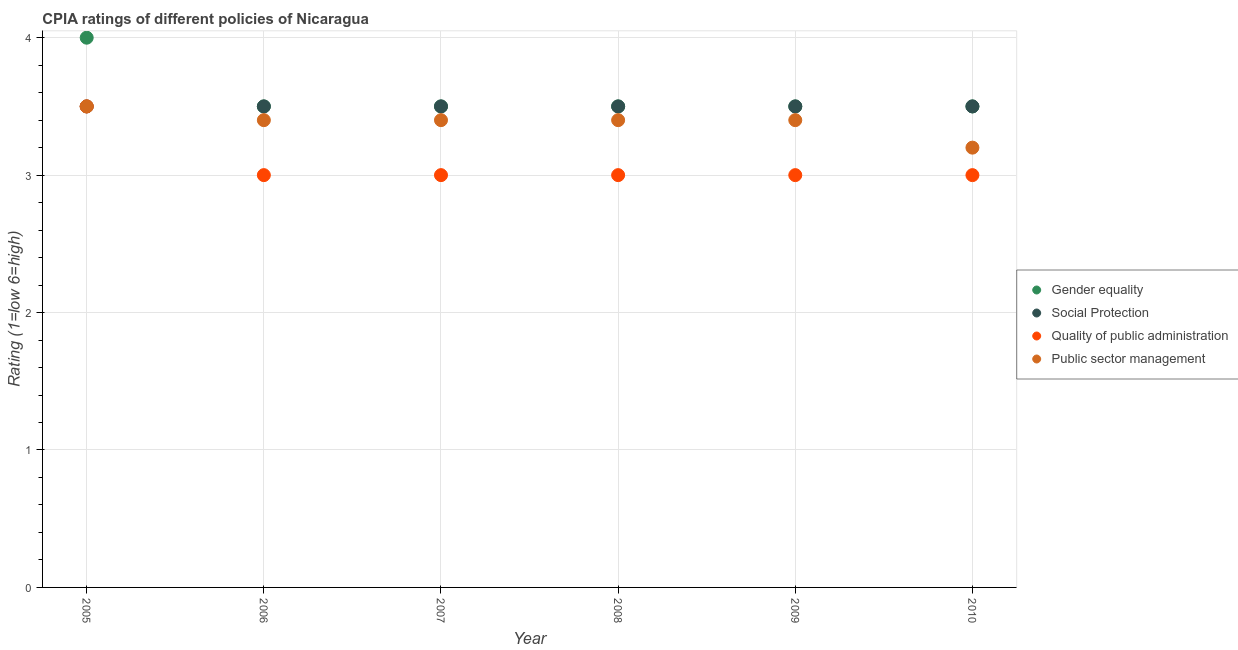How many different coloured dotlines are there?
Make the answer very short. 4. Is the number of dotlines equal to the number of legend labels?
Your answer should be very brief. Yes. Across all years, what is the minimum cpia rating of public sector management?
Provide a succinct answer. 3.2. In which year was the cpia rating of social protection maximum?
Your answer should be very brief. 2005. In which year was the cpia rating of social protection minimum?
Offer a terse response. 2005. What is the total cpia rating of gender equality in the graph?
Offer a terse response. 21.5. What is the difference between the cpia rating of public sector management in 2008 and the cpia rating of gender equality in 2005?
Ensure brevity in your answer.  -0.6. What is the average cpia rating of public sector management per year?
Make the answer very short. 3.38. In how many years, is the cpia rating of public sector management greater than 1.4?
Provide a short and direct response. 6. What is the ratio of the cpia rating of social protection in 2008 to that in 2009?
Ensure brevity in your answer.  1. Is the cpia rating of quality of public administration in 2005 less than that in 2008?
Ensure brevity in your answer.  No. Is the difference between the cpia rating of public sector management in 2006 and 2007 greater than the difference between the cpia rating of quality of public administration in 2006 and 2007?
Keep it short and to the point. No. What is the difference between the highest and the second highest cpia rating of public sector management?
Your response must be concise. 0.1. In how many years, is the cpia rating of social protection greater than the average cpia rating of social protection taken over all years?
Offer a terse response. 0. Is the sum of the cpia rating of quality of public administration in 2006 and 2010 greater than the maximum cpia rating of gender equality across all years?
Offer a terse response. Yes. Is it the case that in every year, the sum of the cpia rating of gender equality and cpia rating of social protection is greater than the cpia rating of quality of public administration?
Offer a terse response. Yes. Does the cpia rating of social protection monotonically increase over the years?
Make the answer very short. No. Is the cpia rating of quality of public administration strictly greater than the cpia rating of public sector management over the years?
Offer a very short reply. No. How many dotlines are there?
Keep it short and to the point. 4. How many years are there in the graph?
Provide a succinct answer. 6. What is the difference between two consecutive major ticks on the Y-axis?
Provide a succinct answer. 1. Are the values on the major ticks of Y-axis written in scientific E-notation?
Offer a very short reply. No. Does the graph contain any zero values?
Give a very brief answer. No. Where does the legend appear in the graph?
Offer a terse response. Center right. How are the legend labels stacked?
Offer a very short reply. Vertical. What is the title of the graph?
Keep it short and to the point. CPIA ratings of different policies of Nicaragua. What is the Rating (1=low 6=high) of Social Protection in 2005?
Offer a very short reply. 3.5. What is the Rating (1=low 6=high) in Public sector management in 2005?
Give a very brief answer. 3.5. What is the Rating (1=low 6=high) of Social Protection in 2006?
Offer a terse response. 3.5. What is the Rating (1=low 6=high) in Quality of public administration in 2006?
Offer a terse response. 3. What is the Rating (1=low 6=high) in Public sector management in 2006?
Keep it short and to the point. 3.4. What is the Rating (1=low 6=high) in Social Protection in 2007?
Your response must be concise. 3.5. What is the Rating (1=low 6=high) in Quality of public administration in 2007?
Give a very brief answer. 3. What is the Rating (1=low 6=high) in Public sector management in 2007?
Offer a terse response. 3.4. What is the Rating (1=low 6=high) in Gender equality in 2008?
Keep it short and to the point. 3.5. What is the Rating (1=low 6=high) of Social Protection in 2008?
Make the answer very short. 3.5. What is the Rating (1=low 6=high) in Public sector management in 2008?
Offer a very short reply. 3.4. What is the Rating (1=low 6=high) of Social Protection in 2009?
Keep it short and to the point. 3.5. What is the Rating (1=low 6=high) in Quality of public administration in 2009?
Ensure brevity in your answer.  3. What is the Rating (1=low 6=high) of Social Protection in 2010?
Make the answer very short. 3.5. Across all years, what is the maximum Rating (1=low 6=high) of Gender equality?
Your answer should be very brief. 4. Across all years, what is the maximum Rating (1=low 6=high) of Quality of public administration?
Provide a short and direct response. 3.5. Across all years, what is the minimum Rating (1=low 6=high) in Gender equality?
Provide a short and direct response. 3.5. Across all years, what is the minimum Rating (1=low 6=high) in Social Protection?
Your response must be concise. 3.5. What is the total Rating (1=low 6=high) in Gender equality in the graph?
Your answer should be very brief. 21.5. What is the total Rating (1=low 6=high) in Public sector management in the graph?
Keep it short and to the point. 20.3. What is the difference between the Rating (1=low 6=high) in Quality of public administration in 2005 and that in 2006?
Provide a short and direct response. 0.5. What is the difference between the Rating (1=low 6=high) of Gender equality in 2005 and that in 2007?
Provide a succinct answer. 0.5. What is the difference between the Rating (1=low 6=high) of Social Protection in 2005 and that in 2007?
Provide a short and direct response. 0. What is the difference between the Rating (1=low 6=high) of Public sector management in 2005 and that in 2007?
Offer a terse response. 0.1. What is the difference between the Rating (1=low 6=high) of Gender equality in 2005 and that in 2008?
Offer a terse response. 0.5. What is the difference between the Rating (1=low 6=high) of Social Protection in 2005 and that in 2008?
Provide a short and direct response. 0. What is the difference between the Rating (1=low 6=high) of Public sector management in 2005 and that in 2008?
Offer a terse response. 0.1. What is the difference between the Rating (1=low 6=high) of Gender equality in 2005 and that in 2009?
Make the answer very short. 0.5. What is the difference between the Rating (1=low 6=high) of Social Protection in 2005 and that in 2009?
Give a very brief answer. 0. What is the difference between the Rating (1=low 6=high) of Public sector management in 2005 and that in 2009?
Offer a very short reply. 0.1. What is the difference between the Rating (1=low 6=high) in Social Protection in 2005 and that in 2010?
Offer a terse response. 0. What is the difference between the Rating (1=low 6=high) of Quality of public administration in 2005 and that in 2010?
Offer a very short reply. 0.5. What is the difference between the Rating (1=low 6=high) of Public sector management in 2005 and that in 2010?
Provide a succinct answer. 0.3. What is the difference between the Rating (1=low 6=high) in Gender equality in 2006 and that in 2007?
Your answer should be compact. 0. What is the difference between the Rating (1=low 6=high) in Social Protection in 2006 and that in 2007?
Offer a very short reply. 0. What is the difference between the Rating (1=low 6=high) in Quality of public administration in 2006 and that in 2007?
Your answer should be compact. 0. What is the difference between the Rating (1=low 6=high) of Gender equality in 2006 and that in 2008?
Make the answer very short. 0. What is the difference between the Rating (1=low 6=high) in Quality of public administration in 2006 and that in 2008?
Give a very brief answer. 0. What is the difference between the Rating (1=low 6=high) of Public sector management in 2006 and that in 2008?
Give a very brief answer. 0. What is the difference between the Rating (1=low 6=high) of Quality of public administration in 2006 and that in 2010?
Give a very brief answer. 0. What is the difference between the Rating (1=low 6=high) in Public sector management in 2006 and that in 2010?
Your answer should be very brief. 0.2. What is the difference between the Rating (1=low 6=high) of Quality of public administration in 2007 and that in 2008?
Make the answer very short. 0. What is the difference between the Rating (1=low 6=high) in Public sector management in 2007 and that in 2008?
Give a very brief answer. 0. What is the difference between the Rating (1=low 6=high) of Gender equality in 2007 and that in 2009?
Ensure brevity in your answer.  0. What is the difference between the Rating (1=low 6=high) in Social Protection in 2007 and that in 2009?
Provide a succinct answer. 0. What is the difference between the Rating (1=low 6=high) of Public sector management in 2007 and that in 2009?
Ensure brevity in your answer.  0. What is the difference between the Rating (1=low 6=high) of Quality of public administration in 2007 and that in 2010?
Your answer should be very brief. 0. What is the difference between the Rating (1=low 6=high) of Public sector management in 2007 and that in 2010?
Provide a short and direct response. 0.2. What is the difference between the Rating (1=low 6=high) of Social Protection in 2008 and that in 2009?
Make the answer very short. 0. What is the difference between the Rating (1=low 6=high) in Quality of public administration in 2008 and that in 2009?
Your answer should be very brief. 0. What is the difference between the Rating (1=low 6=high) of Public sector management in 2008 and that in 2009?
Offer a terse response. 0. What is the difference between the Rating (1=low 6=high) in Social Protection in 2008 and that in 2010?
Keep it short and to the point. 0. What is the difference between the Rating (1=low 6=high) in Quality of public administration in 2008 and that in 2010?
Your answer should be compact. 0. What is the difference between the Rating (1=low 6=high) in Public sector management in 2008 and that in 2010?
Provide a succinct answer. 0.2. What is the difference between the Rating (1=low 6=high) of Gender equality in 2009 and that in 2010?
Offer a terse response. 0. What is the difference between the Rating (1=low 6=high) of Public sector management in 2009 and that in 2010?
Provide a succinct answer. 0.2. What is the difference between the Rating (1=low 6=high) of Gender equality in 2005 and the Rating (1=low 6=high) of Social Protection in 2006?
Provide a succinct answer. 0.5. What is the difference between the Rating (1=low 6=high) of Gender equality in 2005 and the Rating (1=low 6=high) of Quality of public administration in 2006?
Your response must be concise. 1. What is the difference between the Rating (1=low 6=high) of Gender equality in 2005 and the Rating (1=low 6=high) of Public sector management in 2006?
Your response must be concise. 0.6. What is the difference between the Rating (1=low 6=high) of Social Protection in 2005 and the Rating (1=low 6=high) of Public sector management in 2006?
Ensure brevity in your answer.  0.1. What is the difference between the Rating (1=low 6=high) of Gender equality in 2005 and the Rating (1=low 6=high) of Social Protection in 2007?
Provide a short and direct response. 0.5. What is the difference between the Rating (1=low 6=high) in Social Protection in 2005 and the Rating (1=low 6=high) in Quality of public administration in 2007?
Offer a very short reply. 0.5. What is the difference between the Rating (1=low 6=high) in Social Protection in 2005 and the Rating (1=low 6=high) in Public sector management in 2007?
Offer a very short reply. 0.1. What is the difference between the Rating (1=low 6=high) in Quality of public administration in 2005 and the Rating (1=low 6=high) in Public sector management in 2007?
Offer a very short reply. 0.1. What is the difference between the Rating (1=low 6=high) of Gender equality in 2005 and the Rating (1=low 6=high) of Social Protection in 2008?
Provide a succinct answer. 0.5. What is the difference between the Rating (1=low 6=high) in Gender equality in 2005 and the Rating (1=low 6=high) in Quality of public administration in 2008?
Provide a succinct answer. 1. What is the difference between the Rating (1=low 6=high) of Gender equality in 2005 and the Rating (1=low 6=high) of Public sector management in 2008?
Make the answer very short. 0.6. What is the difference between the Rating (1=low 6=high) of Social Protection in 2005 and the Rating (1=low 6=high) of Quality of public administration in 2008?
Keep it short and to the point. 0.5. What is the difference between the Rating (1=low 6=high) in Gender equality in 2005 and the Rating (1=low 6=high) in Social Protection in 2009?
Ensure brevity in your answer.  0.5. What is the difference between the Rating (1=low 6=high) in Gender equality in 2005 and the Rating (1=low 6=high) in Quality of public administration in 2009?
Offer a very short reply. 1. What is the difference between the Rating (1=low 6=high) in Gender equality in 2005 and the Rating (1=low 6=high) in Public sector management in 2009?
Your answer should be very brief. 0.6. What is the difference between the Rating (1=low 6=high) of Social Protection in 2005 and the Rating (1=low 6=high) of Public sector management in 2009?
Your answer should be very brief. 0.1. What is the difference between the Rating (1=low 6=high) of Gender equality in 2005 and the Rating (1=low 6=high) of Social Protection in 2010?
Keep it short and to the point. 0.5. What is the difference between the Rating (1=low 6=high) of Gender equality in 2005 and the Rating (1=low 6=high) of Public sector management in 2010?
Offer a terse response. 0.8. What is the difference between the Rating (1=low 6=high) in Social Protection in 2005 and the Rating (1=low 6=high) in Quality of public administration in 2010?
Provide a short and direct response. 0.5. What is the difference between the Rating (1=low 6=high) of Quality of public administration in 2005 and the Rating (1=low 6=high) of Public sector management in 2010?
Ensure brevity in your answer.  0.3. What is the difference between the Rating (1=low 6=high) in Gender equality in 2006 and the Rating (1=low 6=high) in Quality of public administration in 2007?
Give a very brief answer. 0.5. What is the difference between the Rating (1=low 6=high) of Gender equality in 2006 and the Rating (1=low 6=high) of Public sector management in 2007?
Make the answer very short. 0.1. What is the difference between the Rating (1=low 6=high) of Gender equality in 2006 and the Rating (1=low 6=high) of Social Protection in 2008?
Keep it short and to the point. 0. What is the difference between the Rating (1=low 6=high) of Social Protection in 2006 and the Rating (1=low 6=high) of Quality of public administration in 2008?
Make the answer very short. 0.5. What is the difference between the Rating (1=low 6=high) in Social Protection in 2006 and the Rating (1=low 6=high) in Public sector management in 2008?
Make the answer very short. 0.1. What is the difference between the Rating (1=low 6=high) of Gender equality in 2006 and the Rating (1=low 6=high) of Social Protection in 2009?
Your answer should be very brief. 0. What is the difference between the Rating (1=low 6=high) in Social Protection in 2006 and the Rating (1=low 6=high) in Quality of public administration in 2009?
Make the answer very short. 0.5. What is the difference between the Rating (1=low 6=high) in Quality of public administration in 2006 and the Rating (1=low 6=high) in Public sector management in 2009?
Your answer should be very brief. -0.4. What is the difference between the Rating (1=low 6=high) in Gender equality in 2006 and the Rating (1=low 6=high) in Social Protection in 2010?
Give a very brief answer. 0. What is the difference between the Rating (1=low 6=high) in Social Protection in 2006 and the Rating (1=low 6=high) in Quality of public administration in 2010?
Make the answer very short. 0.5. What is the difference between the Rating (1=low 6=high) of Quality of public administration in 2006 and the Rating (1=low 6=high) of Public sector management in 2010?
Make the answer very short. -0.2. What is the difference between the Rating (1=low 6=high) of Gender equality in 2007 and the Rating (1=low 6=high) of Social Protection in 2008?
Give a very brief answer. 0. What is the difference between the Rating (1=low 6=high) in Gender equality in 2007 and the Rating (1=low 6=high) in Quality of public administration in 2008?
Provide a succinct answer. 0.5. What is the difference between the Rating (1=low 6=high) of Social Protection in 2007 and the Rating (1=low 6=high) of Quality of public administration in 2008?
Keep it short and to the point. 0.5. What is the difference between the Rating (1=low 6=high) in Social Protection in 2007 and the Rating (1=low 6=high) in Public sector management in 2008?
Keep it short and to the point. 0.1. What is the difference between the Rating (1=low 6=high) of Gender equality in 2007 and the Rating (1=low 6=high) of Quality of public administration in 2009?
Your response must be concise. 0.5. What is the difference between the Rating (1=low 6=high) of Social Protection in 2007 and the Rating (1=low 6=high) of Quality of public administration in 2009?
Make the answer very short. 0.5. What is the difference between the Rating (1=low 6=high) of Quality of public administration in 2007 and the Rating (1=low 6=high) of Public sector management in 2009?
Provide a succinct answer. -0.4. What is the difference between the Rating (1=low 6=high) in Social Protection in 2007 and the Rating (1=low 6=high) in Quality of public administration in 2010?
Your answer should be very brief. 0.5. What is the difference between the Rating (1=low 6=high) in Quality of public administration in 2007 and the Rating (1=low 6=high) in Public sector management in 2010?
Your response must be concise. -0.2. What is the difference between the Rating (1=low 6=high) in Gender equality in 2008 and the Rating (1=low 6=high) in Social Protection in 2009?
Your answer should be compact. 0. What is the difference between the Rating (1=low 6=high) in Gender equality in 2008 and the Rating (1=low 6=high) in Quality of public administration in 2009?
Your answer should be very brief. 0.5. What is the difference between the Rating (1=low 6=high) of Social Protection in 2008 and the Rating (1=low 6=high) of Quality of public administration in 2009?
Provide a short and direct response. 0.5. What is the difference between the Rating (1=low 6=high) in Social Protection in 2008 and the Rating (1=low 6=high) in Public sector management in 2009?
Offer a very short reply. 0.1. What is the difference between the Rating (1=low 6=high) of Quality of public administration in 2008 and the Rating (1=low 6=high) of Public sector management in 2009?
Give a very brief answer. -0.4. What is the difference between the Rating (1=low 6=high) of Gender equality in 2008 and the Rating (1=low 6=high) of Social Protection in 2010?
Your answer should be very brief. 0. What is the difference between the Rating (1=low 6=high) in Gender equality in 2008 and the Rating (1=low 6=high) in Quality of public administration in 2010?
Your response must be concise. 0.5. What is the difference between the Rating (1=low 6=high) of Quality of public administration in 2008 and the Rating (1=low 6=high) of Public sector management in 2010?
Your answer should be compact. -0.2. What is the difference between the Rating (1=low 6=high) of Gender equality in 2009 and the Rating (1=low 6=high) of Quality of public administration in 2010?
Give a very brief answer. 0.5. What is the difference between the Rating (1=low 6=high) of Social Protection in 2009 and the Rating (1=low 6=high) of Quality of public administration in 2010?
Your answer should be compact. 0.5. What is the difference between the Rating (1=low 6=high) in Quality of public administration in 2009 and the Rating (1=low 6=high) in Public sector management in 2010?
Offer a very short reply. -0.2. What is the average Rating (1=low 6=high) of Gender equality per year?
Your response must be concise. 3.58. What is the average Rating (1=low 6=high) of Social Protection per year?
Make the answer very short. 3.5. What is the average Rating (1=low 6=high) in Quality of public administration per year?
Offer a very short reply. 3.08. What is the average Rating (1=low 6=high) in Public sector management per year?
Keep it short and to the point. 3.38. In the year 2005, what is the difference between the Rating (1=low 6=high) of Gender equality and Rating (1=low 6=high) of Social Protection?
Make the answer very short. 0.5. In the year 2005, what is the difference between the Rating (1=low 6=high) in Gender equality and Rating (1=low 6=high) in Quality of public administration?
Offer a terse response. 0.5. In the year 2005, what is the difference between the Rating (1=low 6=high) of Gender equality and Rating (1=low 6=high) of Public sector management?
Your response must be concise. 0.5. In the year 2005, what is the difference between the Rating (1=low 6=high) in Social Protection and Rating (1=low 6=high) in Quality of public administration?
Offer a very short reply. 0. In the year 2005, what is the difference between the Rating (1=low 6=high) in Quality of public administration and Rating (1=low 6=high) in Public sector management?
Make the answer very short. 0. In the year 2006, what is the difference between the Rating (1=low 6=high) in Gender equality and Rating (1=low 6=high) in Public sector management?
Your answer should be compact. 0.1. In the year 2006, what is the difference between the Rating (1=low 6=high) of Social Protection and Rating (1=low 6=high) of Quality of public administration?
Offer a terse response. 0.5. In the year 2006, what is the difference between the Rating (1=low 6=high) in Social Protection and Rating (1=low 6=high) in Public sector management?
Give a very brief answer. 0.1. In the year 2006, what is the difference between the Rating (1=low 6=high) in Quality of public administration and Rating (1=low 6=high) in Public sector management?
Give a very brief answer. -0.4. In the year 2007, what is the difference between the Rating (1=low 6=high) in Gender equality and Rating (1=low 6=high) in Social Protection?
Provide a short and direct response. 0. In the year 2007, what is the difference between the Rating (1=low 6=high) in Gender equality and Rating (1=low 6=high) in Quality of public administration?
Give a very brief answer. 0.5. In the year 2007, what is the difference between the Rating (1=low 6=high) of Gender equality and Rating (1=low 6=high) of Public sector management?
Give a very brief answer. 0.1. In the year 2007, what is the difference between the Rating (1=low 6=high) of Social Protection and Rating (1=low 6=high) of Quality of public administration?
Make the answer very short. 0.5. In the year 2008, what is the difference between the Rating (1=low 6=high) of Gender equality and Rating (1=low 6=high) of Social Protection?
Provide a succinct answer. 0. In the year 2008, what is the difference between the Rating (1=low 6=high) in Gender equality and Rating (1=low 6=high) in Public sector management?
Ensure brevity in your answer.  0.1. In the year 2008, what is the difference between the Rating (1=low 6=high) in Social Protection and Rating (1=low 6=high) in Public sector management?
Provide a succinct answer. 0.1. In the year 2008, what is the difference between the Rating (1=low 6=high) of Quality of public administration and Rating (1=low 6=high) of Public sector management?
Ensure brevity in your answer.  -0.4. In the year 2009, what is the difference between the Rating (1=low 6=high) of Gender equality and Rating (1=low 6=high) of Public sector management?
Give a very brief answer. 0.1. In the year 2009, what is the difference between the Rating (1=low 6=high) of Quality of public administration and Rating (1=low 6=high) of Public sector management?
Provide a succinct answer. -0.4. In the year 2010, what is the difference between the Rating (1=low 6=high) of Gender equality and Rating (1=low 6=high) of Quality of public administration?
Give a very brief answer. 0.5. In the year 2010, what is the difference between the Rating (1=low 6=high) of Gender equality and Rating (1=low 6=high) of Public sector management?
Keep it short and to the point. 0.3. In the year 2010, what is the difference between the Rating (1=low 6=high) of Social Protection and Rating (1=low 6=high) of Public sector management?
Make the answer very short. 0.3. What is the ratio of the Rating (1=low 6=high) in Gender equality in 2005 to that in 2006?
Ensure brevity in your answer.  1.14. What is the ratio of the Rating (1=low 6=high) in Social Protection in 2005 to that in 2006?
Your response must be concise. 1. What is the ratio of the Rating (1=low 6=high) of Public sector management in 2005 to that in 2006?
Provide a succinct answer. 1.03. What is the ratio of the Rating (1=low 6=high) of Quality of public administration in 2005 to that in 2007?
Provide a succinct answer. 1.17. What is the ratio of the Rating (1=low 6=high) in Public sector management in 2005 to that in 2007?
Your response must be concise. 1.03. What is the ratio of the Rating (1=low 6=high) of Quality of public administration in 2005 to that in 2008?
Offer a terse response. 1.17. What is the ratio of the Rating (1=low 6=high) of Public sector management in 2005 to that in 2008?
Make the answer very short. 1.03. What is the ratio of the Rating (1=low 6=high) of Gender equality in 2005 to that in 2009?
Provide a short and direct response. 1.14. What is the ratio of the Rating (1=low 6=high) of Public sector management in 2005 to that in 2009?
Give a very brief answer. 1.03. What is the ratio of the Rating (1=low 6=high) in Gender equality in 2005 to that in 2010?
Offer a very short reply. 1.14. What is the ratio of the Rating (1=low 6=high) in Social Protection in 2005 to that in 2010?
Offer a terse response. 1. What is the ratio of the Rating (1=low 6=high) in Public sector management in 2005 to that in 2010?
Ensure brevity in your answer.  1.09. What is the ratio of the Rating (1=low 6=high) of Quality of public administration in 2006 to that in 2008?
Your response must be concise. 1. What is the ratio of the Rating (1=low 6=high) of Public sector management in 2006 to that in 2008?
Your answer should be compact. 1. What is the ratio of the Rating (1=low 6=high) in Gender equality in 2006 to that in 2009?
Keep it short and to the point. 1. What is the ratio of the Rating (1=low 6=high) of Quality of public administration in 2006 to that in 2009?
Offer a very short reply. 1. What is the ratio of the Rating (1=low 6=high) of Social Protection in 2006 to that in 2010?
Offer a terse response. 1. What is the ratio of the Rating (1=low 6=high) in Quality of public administration in 2006 to that in 2010?
Offer a terse response. 1. What is the ratio of the Rating (1=low 6=high) in Public sector management in 2006 to that in 2010?
Ensure brevity in your answer.  1.06. What is the ratio of the Rating (1=low 6=high) in Gender equality in 2007 to that in 2008?
Offer a very short reply. 1. What is the ratio of the Rating (1=low 6=high) in Social Protection in 2007 to that in 2008?
Keep it short and to the point. 1. What is the ratio of the Rating (1=low 6=high) in Public sector management in 2007 to that in 2008?
Your response must be concise. 1. What is the ratio of the Rating (1=low 6=high) of Gender equality in 2007 to that in 2009?
Ensure brevity in your answer.  1. What is the ratio of the Rating (1=low 6=high) in Social Protection in 2007 to that in 2009?
Your answer should be compact. 1. What is the ratio of the Rating (1=low 6=high) of Gender equality in 2007 to that in 2010?
Provide a short and direct response. 1. What is the ratio of the Rating (1=low 6=high) in Social Protection in 2007 to that in 2010?
Your response must be concise. 1. What is the ratio of the Rating (1=low 6=high) of Quality of public administration in 2007 to that in 2010?
Offer a very short reply. 1. What is the ratio of the Rating (1=low 6=high) in Gender equality in 2008 to that in 2009?
Keep it short and to the point. 1. What is the ratio of the Rating (1=low 6=high) of Social Protection in 2008 to that in 2009?
Make the answer very short. 1. What is the ratio of the Rating (1=low 6=high) of Gender equality in 2008 to that in 2010?
Your answer should be very brief. 1. What is the ratio of the Rating (1=low 6=high) in Social Protection in 2008 to that in 2010?
Give a very brief answer. 1. What is the ratio of the Rating (1=low 6=high) of Gender equality in 2009 to that in 2010?
Your response must be concise. 1. What is the ratio of the Rating (1=low 6=high) in Social Protection in 2009 to that in 2010?
Make the answer very short. 1. What is the difference between the highest and the second highest Rating (1=low 6=high) of Gender equality?
Your answer should be compact. 0.5. What is the difference between the highest and the second highest Rating (1=low 6=high) in Quality of public administration?
Offer a terse response. 0.5. What is the difference between the highest and the lowest Rating (1=low 6=high) of Gender equality?
Ensure brevity in your answer.  0.5. What is the difference between the highest and the lowest Rating (1=low 6=high) of Quality of public administration?
Provide a short and direct response. 0.5. What is the difference between the highest and the lowest Rating (1=low 6=high) in Public sector management?
Your answer should be compact. 0.3. 